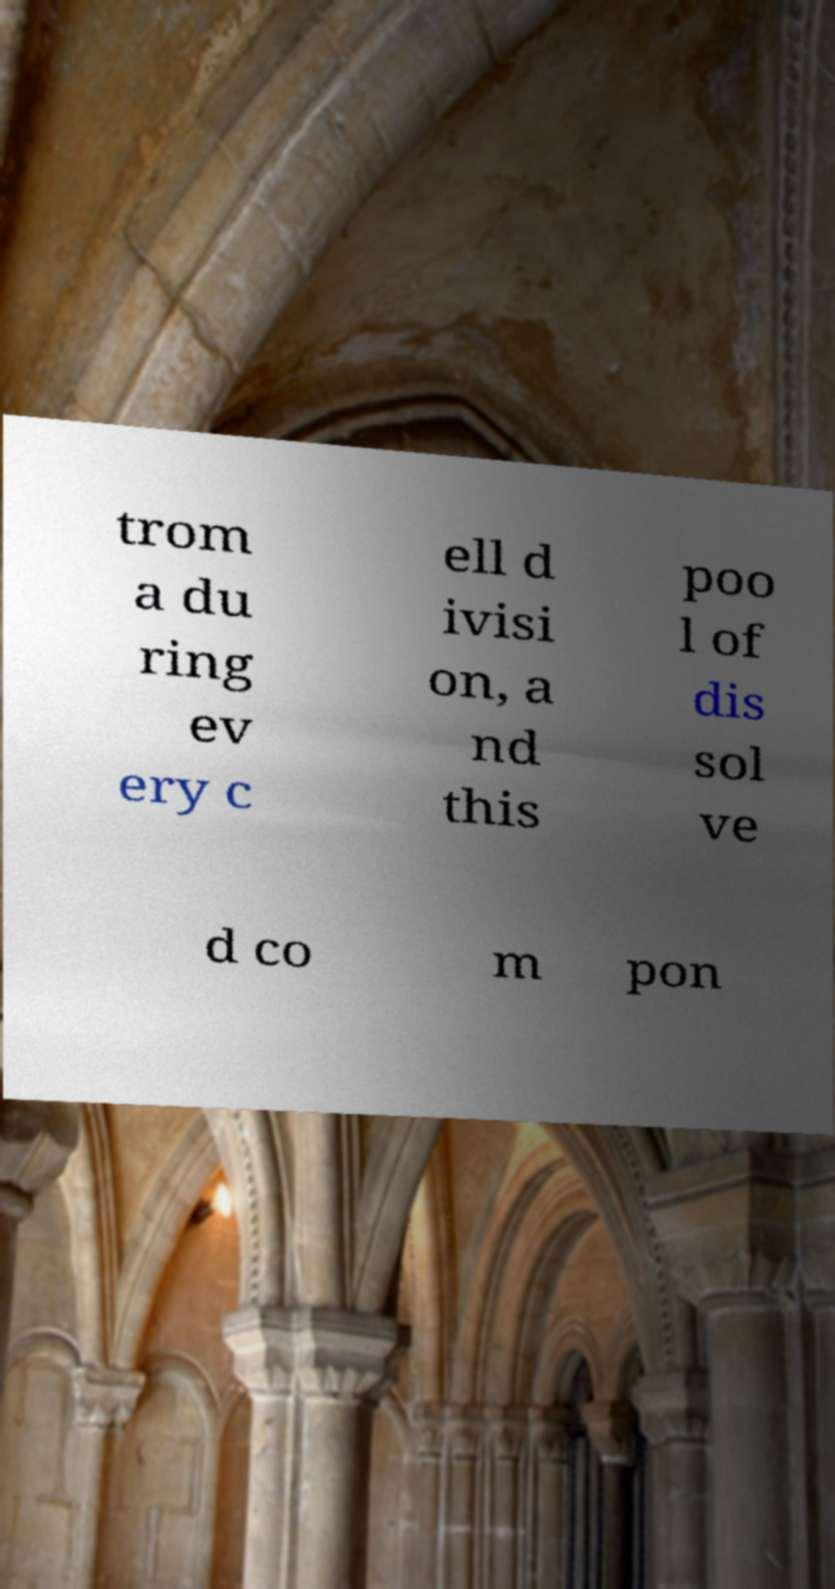Could you assist in decoding the text presented in this image and type it out clearly? trom a du ring ev ery c ell d ivisi on, a nd this poo l of dis sol ve d co m pon 